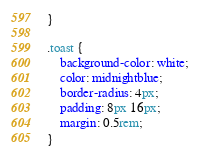Convert code to text. <code><loc_0><loc_0><loc_500><loc_500><_CSS_>}

.toast {
	background-color: white;
	color: midnightblue;
	border-radius: 4px;
	padding: 8px 16px;
	margin: 0.5rem;
}
</code> 